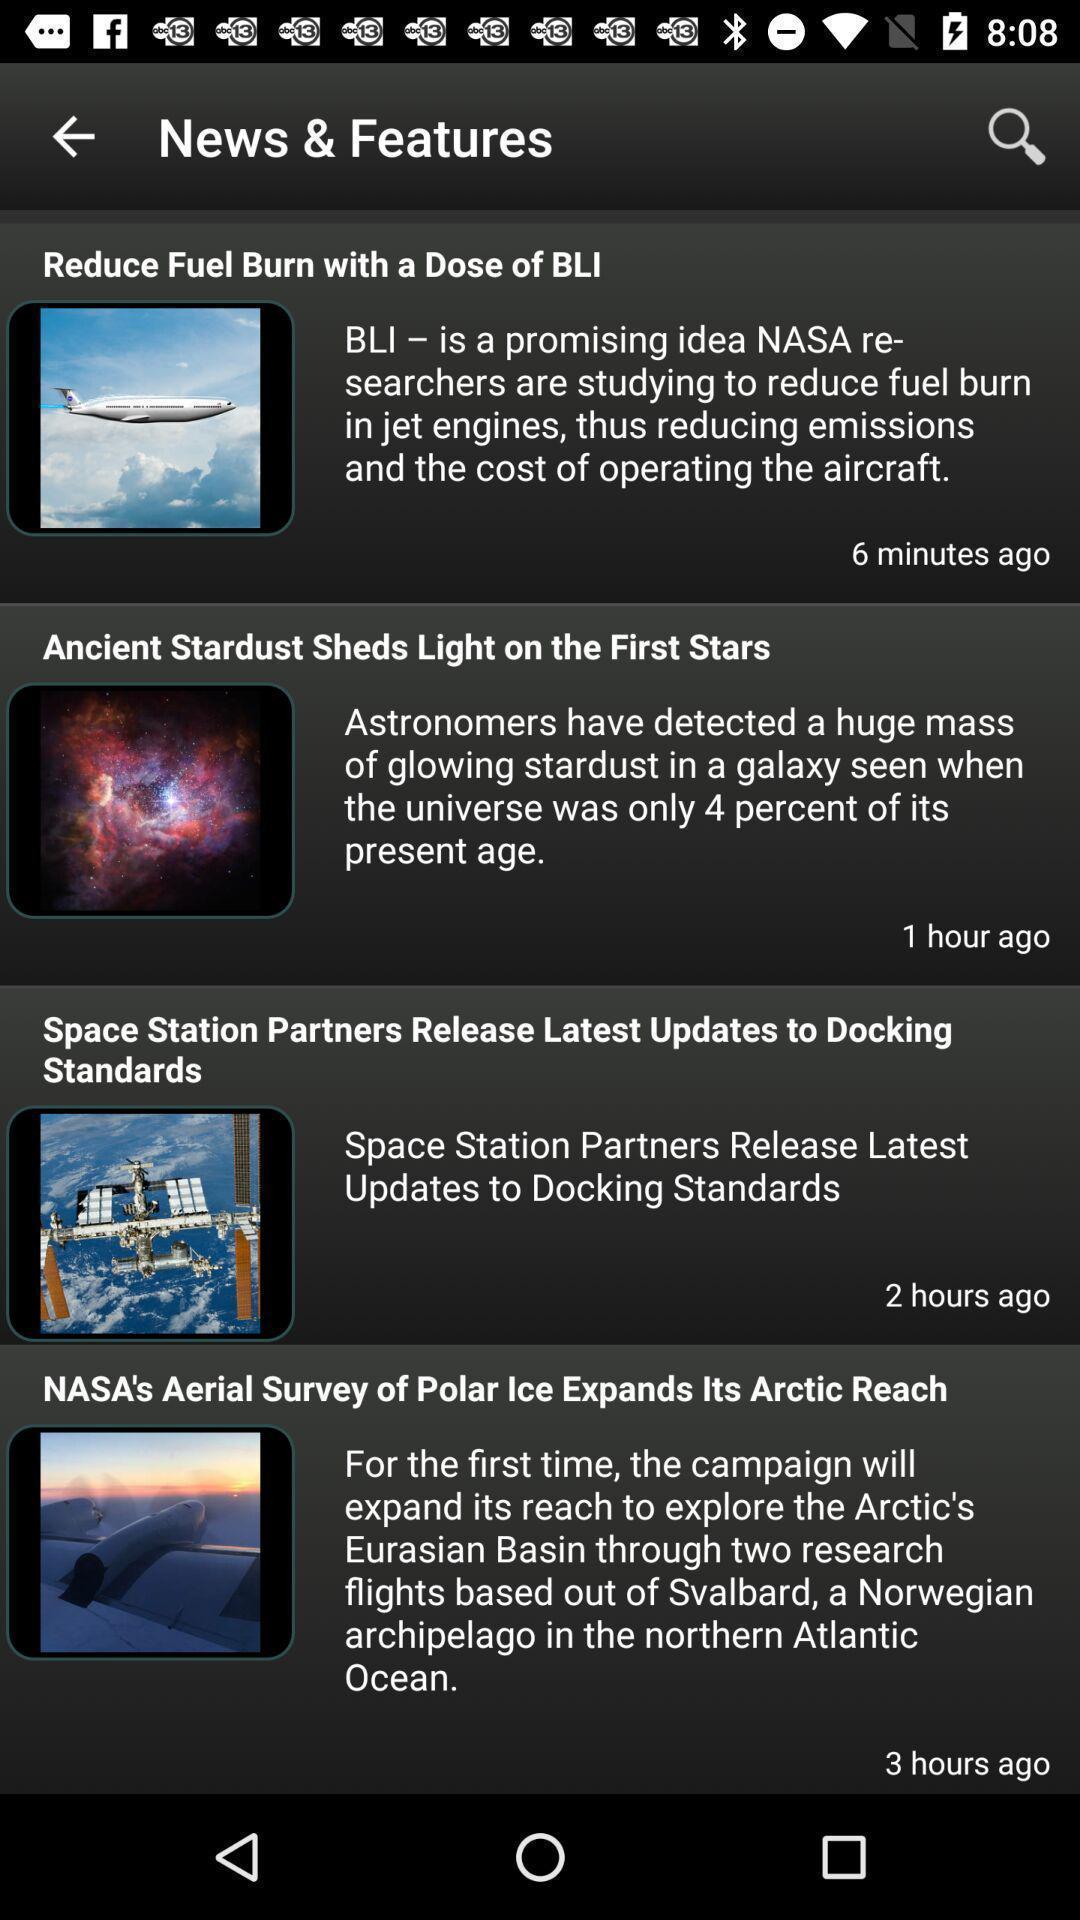Provide a description of this screenshot. Page showing news section of an aviation app. 